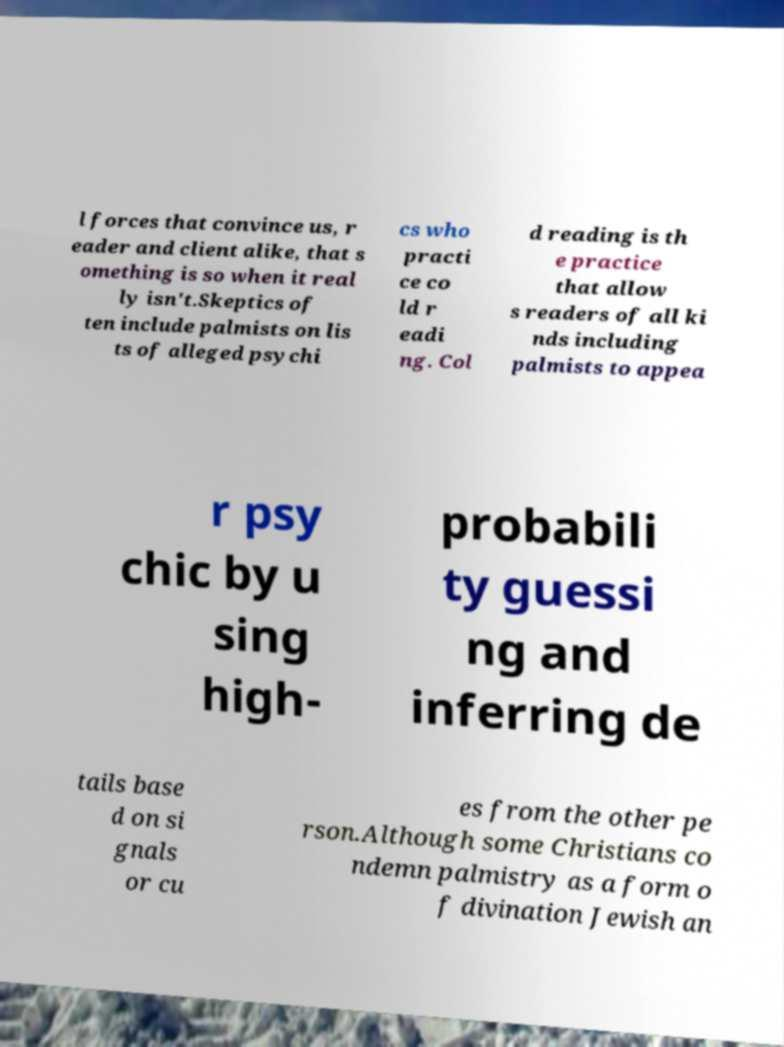Please identify and transcribe the text found in this image. l forces that convince us, r eader and client alike, that s omething is so when it real ly isn't.Skeptics of ten include palmists on lis ts of alleged psychi cs who practi ce co ld r eadi ng. Col d reading is th e practice that allow s readers of all ki nds including palmists to appea r psy chic by u sing high- probabili ty guessi ng and inferring de tails base d on si gnals or cu es from the other pe rson.Although some Christians co ndemn palmistry as a form o f divination Jewish an 